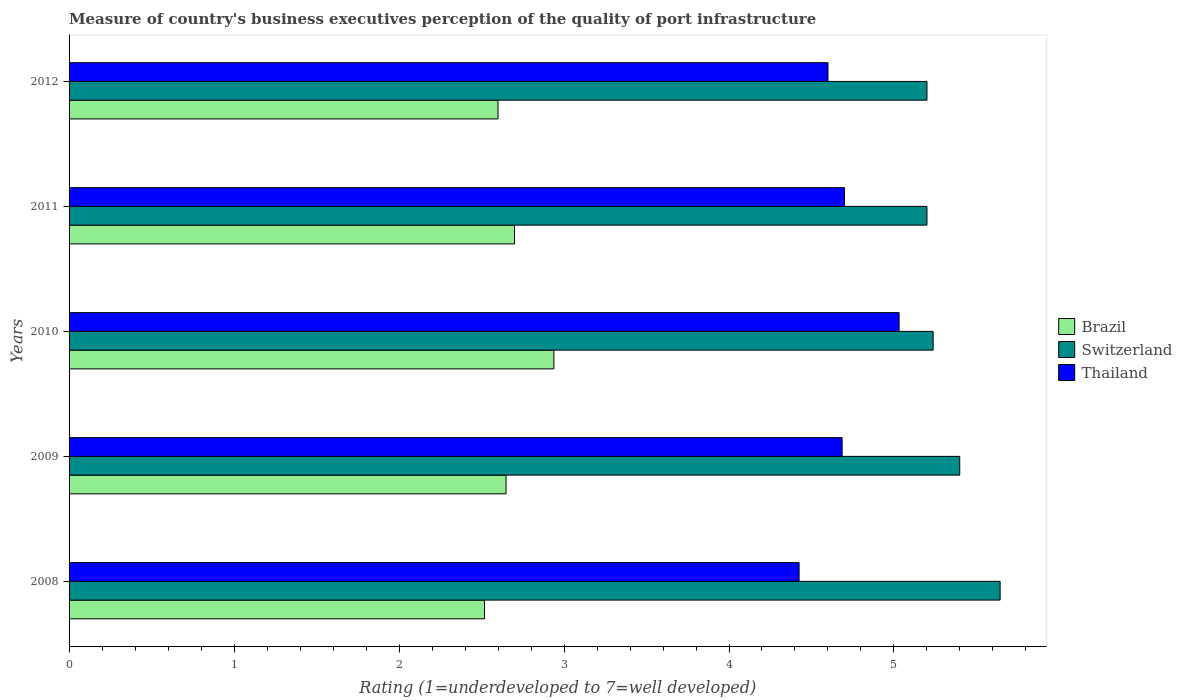Are the number of bars on each tick of the Y-axis equal?
Provide a short and direct response. Yes. How many bars are there on the 2nd tick from the top?
Make the answer very short. 3. How many bars are there on the 3rd tick from the bottom?
Keep it short and to the point. 3. What is the label of the 2nd group of bars from the top?
Your answer should be compact. 2011. What is the ratings of the quality of port infrastructure in Brazil in 2008?
Give a very brief answer. 2.52. Across all years, what is the maximum ratings of the quality of port infrastructure in Thailand?
Make the answer very short. 5.03. Across all years, what is the minimum ratings of the quality of port infrastructure in Brazil?
Offer a very short reply. 2.52. In which year was the ratings of the quality of port infrastructure in Thailand minimum?
Make the answer very short. 2008. What is the total ratings of the quality of port infrastructure in Thailand in the graph?
Keep it short and to the point. 23.44. What is the difference between the ratings of the quality of port infrastructure in Brazil in 2010 and the ratings of the quality of port infrastructure in Switzerland in 2012?
Give a very brief answer. -2.26. What is the average ratings of the quality of port infrastructure in Switzerland per year?
Your answer should be compact. 5.34. In the year 2008, what is the difference between the ratings of the quality of port infrastructure in Thailand and ratings of the quality of port infrastructure in Switzerland?
Make the answer very short. -1.22. What is the ratio of the ratings of the quality of port infrastructure in Thailand in 2009 to that in 2011?
Ensure brevity in your answer.  1. Is the ratings of the quality of port infrastructure in Switzerland in 2010 less than that in 2012?
Ensure brevity in your answer.  No. Is the difference between the ratings of the quality of port infrastructure in Thailand in 2011 and 2012 greater than the difference between the ratings of the quality of port infrastructure in Switzerland in 2011 and 2012?
Your answer should be very brief. Yes. What is the difference between the highest and the second highest ratings of the quality of port infrastructure in Thailand?
Offer a very short reply. 0.33. What is the difference between the highest and the lowest ratings of the quality of port infrastructure in Switzerland?
Provide a short and direct response. 0.44. In how many years, is the ratings of the quality of port infrastructure in Switzerland greater than the average ratings of the quality of port infrastructure in Switzerland taken over all years?
Your answer should be very brief. 2. What does the 3rd bar from the top in 2012 represents?
Your answer should be very brief. Brazil. What does the 2nd bar from the bottom in 2012 represents?
Give a very brief answer. Switzerland. How many bars are there?
Give a very brief answer. 15. How many years are there in the graph?
Give a very brief answer. 5. Are the values on the major ticks of X-axis written in scientific E-notation?
Your response must be concise. No. Does the graph contain grids?
Offer a very short reply. No. How many legend labels are there?
Your response must be concise. 3. How are the legend labels stacked?
Your answer should be very brief. Vertical. What is the title of the graph?
Your answer should be compact. Measure of country's business executives perception of the quality of port infrastructure. What is the label or title of the X-axis?
Offer a terse response. Rating (1=underdeveloped to 7=well developed). What is the Rating (1=underdeveloped to 7=well developed) in Brazil in 2008?
Ensure brevity in your answer.  2.52. What is the Rating (1=underdeveloped to 7=well developed) in Switzerland in 2008?
Offer a terse response. 5.64. What is the Rating (1=underdeveloped to 7=well developed) in Thailand in 2008?
Ensure brevity in your answer.  4.42. What is the Rating (1=underdeveloped to 7=well developed) in Brazil in 2009?
Provide a succinct answer. 2.65. What is the Rating (1=underdeveloped to 7=well developed) in Switzerland in 2009?
Your response must be concise. 5.4. What is the Rating (1=underdeveloped to 7=well developed) in Thailand in 2009?
Your answer should be compact. 4.69. What is the Rating (1=underdeveloped to 7=well developed) of Brazil in 2010?
Your answer should be compact. 2.94. What is the Rating (1=underdeveloped to 7=well developed) of Switzerland in 2010?
Your answer should be very brief. 5.24. What is the Rating (1=underdeveloped to 7=well developed) of Thailand in 2010?
Offer a very short reply. 5.03. What is the Rating (1=underdeveloped to 7=well developed) in Thailand in 2011?
Your response must be concise. 4.7. What is the Rating (1=underdeveloped to 7=well developed) in Brazil in 2012?
Ensure brevity in your answer.  2.6. What is the Rating (1=underdeveloped to 7=well developed) of Switzerland in 2012?
Give a very brief answer. 5.2. What is the Rating (1=underdeveloped to 7=well developed) in Thailand in 2012?
Provide a short and direct response. 4.6. Across all years, what is the maximum Rating (1=underdeveloped to 7=well developed) of Brazil?
Make the answer very short. 2.94. Across all years, what is the maximum Rating (1=underdeveloped to 7=well developed) of Switzerland?
Ensure brevity in your answer.  5.64. Across all years, what is the maximum Rating (1=underdeveloped to 7=well developed) in Thailand?
Give a very brief answer. 5.03. Across all years, what is the minimum Rating (1=underdeveloped to 7=well developed) in Brazil?
Offer a terse response. 2.52. Across all years, what is the minimum Rating (1=underdeveloped to 7=well developed) of Switzerland?
Make the answer very short. 5.2. Across all years, what is the minimum Rating (1=underdeveloped to 7=well developed) of Thailand?
Your answer should be compact. 4.42. What is the total Rating (1=underdeveloped to 7=well developed) of Brazil in the graph?
Make the answer very short. 13.41. What is the total Rating (1=underdeveloped to 7=well developed) of Switzerland in the graph?
Keep it short and to the point. 26.68. What is the total Rating (1=underdeveloped to 7=well developed) in Thailand in the graph?
Provide a short and direct response. 23.44. What is the difference between the Rating (1=underdeveloped to 7=well developed) of Brazil in 2008 and that in 2009?
Make the answer very short. -0.13. What is the difference between the Rating (1=underdeveloped to 7=well developed) of Switzerland in 2008 and that in 2009?
Provide a short and direct response. 0.24. What is the difference between the Rating (1=underdeveloped to 7=well developed) in Thailand in 2008 and that in 2009?
Offer a terse response. -0.26. What is the difference between the Rating (1=underdeveloped to 7=well developed) in Brazil in 2008 and that in 2010?
Give a very brief answer. -0.42. What is the difference between the Rating (1=underdeveloped to 7=well developed) in Switzerland in 2008 and that in 2010?
Your response must be concise. 0.41. What is the difference between the Rating (1=underdeveloped to 7=well developed) in Thailand in 2008 and that in 2010?
Provide a short and direct response. -0.61. What is the difference between the Rating (1=underdeveloped to 7=well developed) of Brazil in 2008 and that in 2011?
Ensure brevity in your answer.  -0.18. What is the difference between the Rating (1=underdeveloped to 7=well developed) in Switzerland in 2008 and that in 2011?
Provide a short and direct response. 0.44. What is the difference between the Rating (1=underdeveloped to 7=well developed) in Thailand in 2008 and that in 2011?
Ensure brevity in your answer.  -0.28. What is the difference between the Rating (1=underdeveloped to 7=well developed) of Brazil in 2008 and that in 2012?
Your answer should be compact. -0.08. What is the difference between the Rating (1=underdeveloped to 7=well developed) of Switzerland in 2008 and that in 2012?
Your response must be concise. 0.44. What is the difference between the Rating (1=underdeveloped to 7=well developed) of Thailand in 2008 and that in 2012?
Ensure brevity in your answer.  -0.18. What is the difference between the Rating (1=underdeveloped to 7=well developed) in Brazil in 2009 and that in 2010?
Ensure brevity in your answer.  -0.29. What is the difference between the Rating (1=underdeveloped to 7=well developed) in Switzerland in 2009 and that in 2010?
Offer a very short reply. 0.16. What is the difference between the Rating (1=underdeveloped to 7=well developed) of Thailand in 2009 and that in 2010?
Make the answer very short. -0.35. What is the difference between the Rating (1=underdeveloped to 7=well developed) of Brazil in 2009 and that in 2011?
Offer a very short reply. -0.05. What is the difference between the Rating (1=underdeveloped to 7=well developed) in Switzerland in 2009 and that in 2011?
Make the answer very short. 0.2. What is the difference between the Rating (1=underdeveloped to 7=well developed) in Thailand in 2009 and that in 2011?
Your response must be concise. -0.01. What is the difference between the Rating (1=underdeveloped to 7=well developed) in Brazil in 2009 and that in 2012?
Make the answer very short. 0.05. What is the difference between the Rating (1=underdeveloped to 7=well developed) in Switzerland in 2009 and that in 2012?
Provide a short and direct response. 0.2. What is the difference between the Rating (1=underdeveloped to 7=well developed) of Thailand in 2009 and that in 2012?
Provide a succinct answer. 0.09. What is the difference between the Rating (1=underdeveloped to 7=well developed) of Brazil in 2010 and that in 2011?
Your answer should be compact. 0.24. What is the difference between the Rating (1=underdeveloped to 7=well developed) of Switzerland in 2010 and that in 2011?
Keep it short and to the point. 0.04. What is the difference between the Rating (1=underdeveloped to 7=well developed) of Thailand in 2010 and that in 2011?
Give a very brief answer. 0.33. What is the difference between the Rating (1=underdeveloped to 7=well developed) in Brazil in 2010 and that in 2012?
Your answer should be very brief. 0.34. What is the difference between the Rating (1=underdeveloped to 7=well developed) in Switzerland in 2010 and that in 2012?
Your answer should be compact. 0.04. What is the difference between the Rating (1=underdeveloped to 7=well developed) of Thailand in 2010 and that in 2012?
Your answer should be compact. 0.43. What is the difference between the Rating (1=underdeveloped to 7=well developed) in Switzerland in 2011 and that in 2012?
Ensure brevity in your answer.  0. What is the difference between the Rating (1=underdeveloped to 7=well developed) of Thailand in 2011 and that in 2012?
Provide a short and direct response. 0.1. What is the difference between the Rating (1=underdeveloped to 7=well developed) of Brazil in 2008 and the Rating (1=underdeveloped to 7=well developed) of Switzerland in 2009?
Provide a succinct answer. -2.88. What is the difference between the Rating (1=underdeveloped to 7=well developed) of Brazil in 2008 and the Rating (1=underdeveloped to 7=well developed) of Thailand in 2009?
Your answer should be very brief. -2.17. What is the difference between the Rating (1=underdeveloped to 7=well developed) in Switzerland in 2008 and the Rating (1=underdeveloped to 7=well developed) in Thailand in 2009?
Offer a very short reply. 0.96. What is the difference between the Rating (1=underdeveloped to 7=well developed) in Brazil in 2008 and the Rating (1=underdeveloped to 7=well developed) in Switzerland in 2010?
Offer a very short reply. -2.72. What is the difference between the Rating (1=underdeveloped to 7=well developed) in Brazil in 2008 and the Rating (1=underdeveloped to 7=well developed) in Thailand in 2010?
Provide a short and direct response. -2.51. What is the difference between the Rating (1=underdeveloped to 7=well developed) in Switzerland in 2008 and the Rating (1=underdeveloped to 7=well developed) in Thailand in 2010?
Your response must be concise. 0.61. What is the difference between the Rating (1=underdeveloped to 7=well developed) of Brazil in 2008 and the Rating (1=underdeveloped to 7=well developed) of Switzerland in 2011?
Give a very brief answer. -2.68. What is the difference between the Rating (1=underdeveloped to 7=well developed) in Brazil in 2008 and the Rating (1=underdeveloped to 7=well developed) in Thailand in 2011?
Offer a very short reply. -2.18. What is the difference between the Rating (1=underdeveloped to 7=well developed) in Switzerland in 2008 and the Rating (1=underdeveloped to 7=well developed) in Thailand in 2011?
Make the answer very short. 0.94. What is the difference between the Rating (1=underdeveloped to 7=well developed) of Brazil in 2008 and the Rating (1=underdeveloped to 7=well developed) of Switzerland in 2012?
Make the answer very short. -2.68. What is the difference between the Rating (1=underdeveloped to 7=well developed) in Brazil in 2008 and the Rating (1=underdeveloped to 7=well developed) in Thailand in 2012?
Your response must be concise. -2.08. What is the difference between the Rating (1=underdeveloped to 7=well developed) of Switzerland in 2008 and the Rating (1=underdeveloped to 7=well developed) of Thailand in 2012?
Ensure brevity in your answer.  1.04. What is the difference between the Rating (1=underdeveloped to 7=well developed) in Brazil in 2009 and the Rating (1=underdeveloped to 7=well developed) in Switzerland in 2010?
Give a very brief answer. -2.59. What is the difference between the Rating (1=underdeveloped to 7=well developed) of Brazil in 2009 and the Rating (1=underdeveloped to 7=well developed) of Thailand in 2010?
Give a very brief answer. -2.38. What is the difference between the Rating (1=underdeveloped to 7=well developed) of Switzerland in 2009 and the Rating (1=underdeveloped to 7=well developed) of Thailand in 2010?
Your response must be concise. 0.37. What is the difference between the Rating (1=underdeveloped to 7=well developed) of Brazil in 2009 and the Rating (1=underdeveloped to 7=well developed) of Switzerland in 2011?
Provide a short and direct response. -2.55. What is the difference between the Rating (1=underdeveloped to 7=well developed) of Brazil in 2009 and the Rating (1=underdeveloped to 7=well developed) of Thailand in 2011?
Give a very brief answer. -2.05. What is the difference between the Rating (1=underdeveloped to 7=well developed) in Switzerland in 2009 and the Rating (1=underdeveloped to 7=well developed) in Thailand in 2011?
Keep it short and to the point. 0.7. What is the difference between the Rating (1=underdeveloped to 7=well developed) of Brazil in 2009 and the Rating (1=underdeveloped to 7=well developed) of Switzerland in 2012?
Keep it short and to the point. -2.55. What is the difference between the Rating (1=underdeveloped to 7=well developed) of Brazil in 2009 and the Rating (1=underdeveloped to 7=well developed) of Thailand in 2012?
Keep it short and to the point. -1.95. What is the difference between the Rating (1=underdeveloped to 7=well developed) of Switzerland in 2009 and the Rating (1=underdeveloped to 7=well developed) of Thailand in 2012?
Offer a very short reply. 0.8. What is the difference between the Rating (1=underdeveloped to 7=well developed) of Brazil in 2010 and the Rating (1=underdeveloped to 7=well developed) of Switzerland in 2011?
Give a very brief answer. -2.26. What is the difference between the Rating (1=underdeveloped to 7=well developed) of Brazil in 2010 and the Rating (1=underdeveloped to 7=well developed) of Thailand in 2011?
Provide a short and direct response. -1.76. What is the difference between the Rating (1=underdeveloped to 7=well developed) of Switzerland in 2010 and the Rating (1=underdeveloped to 7=well developed) of Thailand in 2011?
Offer a very short reply. 0.54. What is the difference between the Rating (1=underdeveloped to 7=well developed) of Brazil in 2010 and the Rating (1=underdeveloped to 7=well developed) of Switzerland in 2012?
Provide a succinct answer. -2.26. What is the difference between the Rating (1=underdeveloped to 7=well developed) in Brazil in 2010 and the Rating (1=underdeveloped to 7=well developed) in Thailand in 2012?
Give a very brief answer. -1.66. What is the difference between the Rating (1=underdeveloped to 7=well developed) of Switzerland in 2010 and the Rating (1=underdeveloped to 7=well developed) of Thailand in 2012?
Your answer should be very brief. 0.64. What is the difference between the Rating (1=underdeveloped to 7=well developed) in Brazil in 2011 and the Rating (1=underdeveloped to 7=well developed) in Switzerland in 2012?
Make the answer very short. -2.5. What is the difference between the Rating (1=underdeveloped to 7=well developed) in Switzerland in 2011 and the Rating (1=underdeveloped to 7=well developed) in Thailand in 2012?
Provide a short and direct response. 0.6. What is the average Rating (1=underdeveloped to 7=well developed) of Brazil per year?
Your response must be concise. 2.68. What is the average Rating (1=underdeveloped to 7=well developed) of Switzerland per year?
Your answer should be very brief. 5.34. What is the average Rating (1=underdeveloped to 7=well developed) of Thailand per year?
Your answer should be very brief. 4.69. In the year 2008, what is the difference between the Rating (1=underdeveloped to 7=well developed) in Brazil and Rating (1=underdeveloped to 7=well developed) in Switzerland?
Ensure brevity in your answer.  -3.13. In the year 2008, what is the difference between the Rating (1=underdeveloped to 7=well developed) in Brazil and Rating (1=underdeveloped to 7=well developed) in Thailand?
Your answer should be very brief. -1.91. In the year 2008, what is the difference between the Rating (1=underdeveloped to 7=well developed) of Switzerland and Rating (1=underdeveloped to 7=well developed) of Thailand?
Your response must be concise. 1.22. In the year 2009, what is the difference between the Rating (1=underdeveloped to 7=well developed) in Brazil and Rating (1=underdeveloped to 7=well developed) in Switzerland?
Give a very brief answer. -2.75. In the year 2009, what is the difference between the Rating (1=underdeveloped to 7=well developed) of Brazil and Rating (1=underdeveloped to 7=well developed) of Thailand?
Your response must be concise. -2.04. In the year 2009, what is the difference between the Rating (1=underdeveloped to 7=well developed) in Switzerland and Rating (1=underdeveloped to 7=well developed) in Thailand?
Your answer should be very brief. 0.71. In the year 2010, what is the difference between the Rating (1=underdeveloped to 7=well developed) in Brazil and Rating (1=underdeveloped to 7=well developed) in Switzerland?
Provide a succinct answer. -2.3. In the year 2010, what is the difference between the Rating (1=underdeveloped to 7=well developed) of Brazil and Rating (1=underdeveloped to 7=well developed) of Thailand?
Your answer should be compact. -2.09. In the year 2010, what is the difference between the Rating (1=underdeveloped to 7=well developed) of Switzerland and Rating (1=underdeveloped to 7=well developed) of Thailand?
Provide a succinct answer. 0.21. In the year 2011, what is the difference between the Rating (1=underdeveloped to 7=well developed) in Brazil and Rating (1=underdeveloped to 7=well developed) in Switzerland?
Ensure brevity in your answer.  -2.5. In the year 2011, what is the difference between the Rating (1=underdeveloped to 7=well developed) in Brazil and Rating (1=underdeveloped to 7=well developed) in Thailand?
Your answer should be very brief. -2. In the year 2011, what is the difference between the Rating (1=underdeveloped to 7=well developed) in Switzerland and Rating (1=underdeveloped to 7=well developed) in Thailand?
Provide a succinct answer. 0.5. In the year 2012, what is the difference between the Rating (1=underdeveloped to 7=well developed) of Brazil and Rating (1=underdeveloped to 7=well developed) of Thailand?
Your response must be concise. -2. In the year 2012, what is the difference between the Rating (1=underdeveloped to 7=well developed) in Switzerland and Rating (1=underdeveloped to 7=well developed) in Thailand?
Your response must be concise. 0.6. What is the ratio of the Rating (1=underdeveloped to 7=well developed) in Brazil in 2008 to that in 2009?
Provide a short and direct response. 0.95. What is the ratio of the Rating (1=underdeveloped to 7=well developed) of Switzerland in 2008 to that in 2009?
Your answer should be very brief. 1.05. What is the ratio of the Rating (1=underdeveloped to 7=well developed) in Brazil in 2008 to that in 2010?
Offer a very short reply. 0.86. What is the ratio of the Rating (1=underdeveloped to 7=well developed) in Switzerland in 2008 to that in 2010?
Offer a very short reply. 1.08. What is the ratio of the Rating (1=underdeveloped to 7=well developed) in Thailand in 2008 to that in 2010?
Your response must be concise. 0.88. What is the ratio of the Rating (1=underdeveloped to 7=well developed) in Brazil in 2008 to that in 2011?
Your response must be concise. 0.93. What is the ratio of the Rating (1=underdeveloped to 7=well developed) in Switzerland in 2008 to that in 2011?
Offer a terse response. 1.09. What is the ratio of the Rating (1=underdeveloped to 7=well developed) in Thailand in 2008 to that in 2011?
Make the answer very short. 0.94. What is the ratio of the Rating (1=underdeveloped to 7=well developed) of Brazil in 2008 to that in 2012?
Your answer should be very brief. 0.97. What is the ratio of the Rating (1=underdeveloped to 7=well developed) in Switzerland in 2008 to that in 2012?
Your response must be concise. 1.09. What is the ratio of the Rating (1=underdeveloped to 7=well developed) in Thailand in 2008 to that in 2012?
Ensure brevity in your answer.  0.96. What is the ratio of the Rating (1=underdeveloped to 7=well developed) in Brazil in 2009 to that in 2010?
Make the answer very short. 0.9. What is the ratio of the Rating (1=underdeveloped to 7=well developed) of Switzerland in 2009 to that in 2010?
Give a very brief answer. 1.03. What is the ratio of the Rating (1=underdeveloped to 7=well developed) of Thailand in 2009 to that in 2010?
Provide a succinct answer. 0.93. What is the ratio of the Rating (1=underdeveloped to 7=well developed) in Switzerland in 2009 to that in 2011?
Keep it short and to the point. 1.04. What is the ratio of the Rating (1=underdeveloped to 7=well developed) of Thailand in 2009 to that in 2011?
Your answer should be compact. 1. What is the ratio of the Rating (1=underdeveloped to 7=well developed) of Brazil in 2009 to that in 2012?
Provide a succinct answer. 1.02. What is the ratio of the Rating (1=underdeveloped to 7=well developed) in Switzerland in 2009 to that in 2012?
Ensure brevity in your answer.  1.04. What is the ratio of the Rating (1=underdeveloped to 7=well developed) of Thailand in 2009 to that in 2012?
Offer a terse response. 1.02. What is the ratio of the Rating (1=underdeveloped to 7=well developed) of Brazil in 2010 to that in 2011?
Your response must be concise. 1.09. What is the ratio of the Rating (1=underdeveloped to 7=well developed) of Switzerland in 2010 to that in 2011?
Keep it short and to the point. 1.01. What is the ratio of the Rating (1=underdeveloped to 7=well developed) in Thailand in 2010 to that in 2011?
Offer a very short reply. 1.07. What is the ratio of the Rating (1=underdeveloped to 7=well developed) in Brazil in 2010 to that in 2012?
Offer a very short reply. 1.13. What is the ratio of the Rating (1=underdeveloped to 7=well developed) in Switzerland in 2010 to that in 2012?
Offer a terse response. 1.01. What is the ratio of the Rating (1=underdeveloped to 7=well developed) of Thailand in 2010 to that in 2012?
Ensure brevity in your answer.  1.09. What is the ratio of the Rating (1=underdeveloped to 7=well developed) in Thailand in 2011 to that in 2012?
Your response must be concise. 1.02. What is the difference between the highest and the second highest Rating (1=underdeveloped to 7=well developed) of Brazil?
Your answer should be very brief. 0.24. What is the difference between the highest and the second highest Rating (1=underdeveloped to 7=well developed) in Switzerland?
Your answer should be compact. 0.24. What is the difference between the highest and the second highest Rating (1=underdeveloped to 7=well developed) of Thailand?
Give a very brief answer. 0.33. What is the difference between the highest and the lowest Rating (1=underdeveloped to 7=well developed) of Brazil?
Your answer should be very brief. 0.42. What is the difference between the highest and the lowest Rating (1=underdeveloped to 7=well developed) of Switzerland?
Provide a short and direct response. 0.44. What is the difference between the highest and the lowest Rating (1=underdeveloped to 7=well developed) in Thailand?
Offer a terse response. 0.61. 